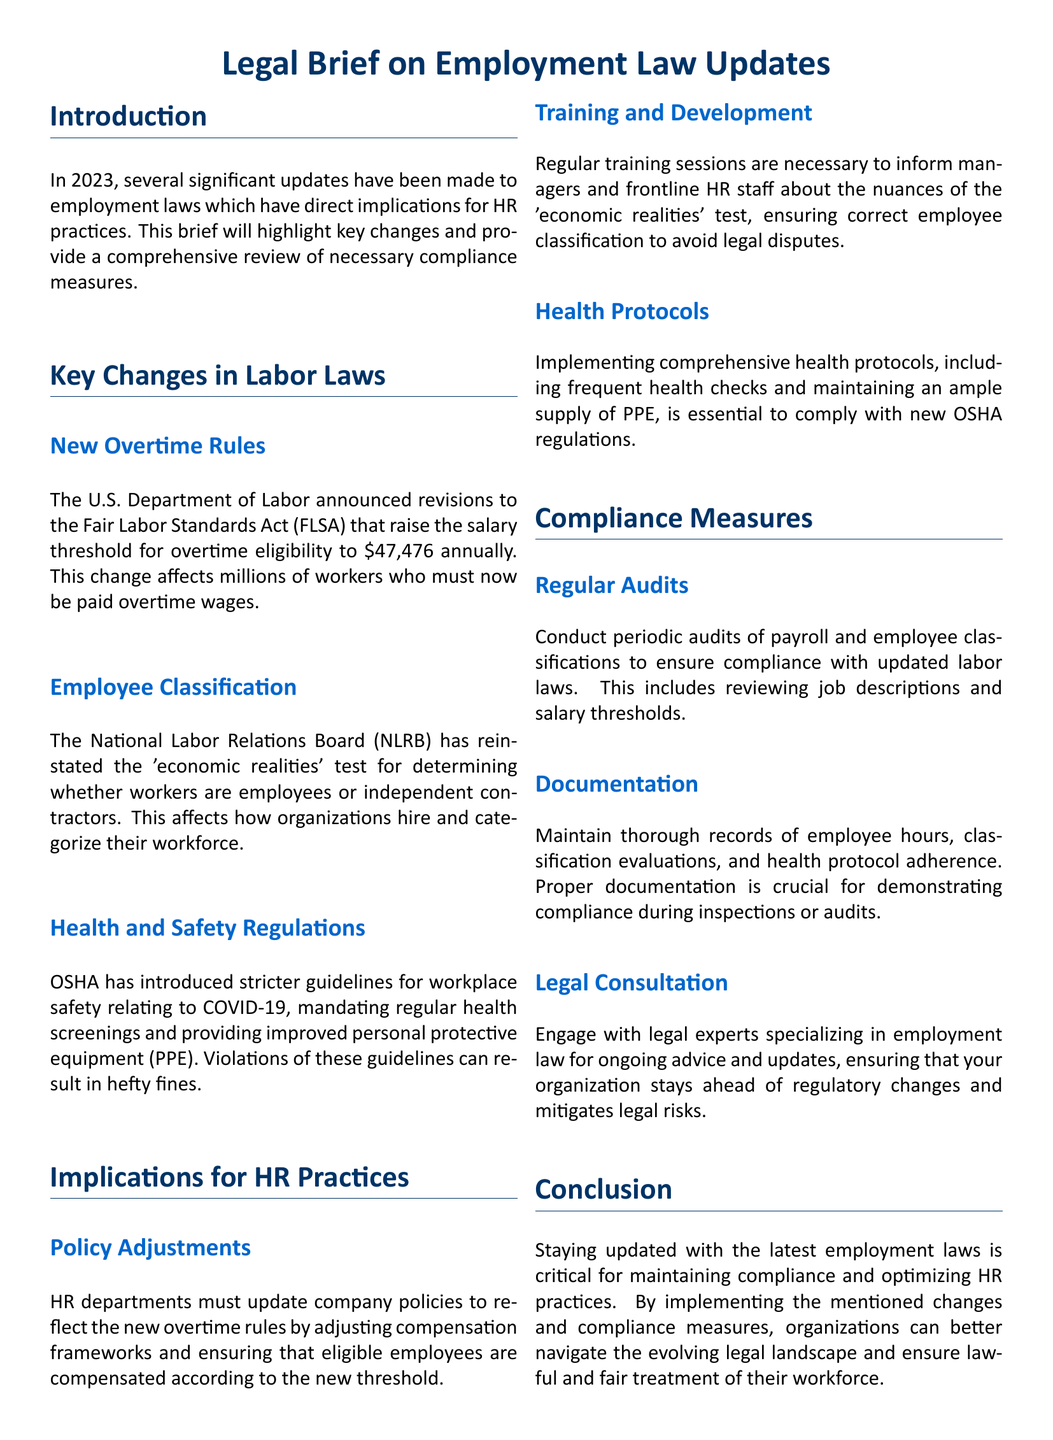What is the new salary threshold for overtime eligibility? The document states that the new salary threshold has been raised to $47,476 annually.
Answer: $47,476 What test was reinstated for employee classification? The document mentions that the 'economic realities' test was reinstated by the NLRB.
Answer: 'economic realities' test What organization introduced stricter workplace safety guidelines? The document notes that OSHA introduced the stricter guidelines for workplace safety.
Answer: OSHA What is one of the compliance measures mentioned for HR? The document lists conducting periodic audits of payroll and employee classifications as a compliance measure.
Answer: Regular audits What must HR update according to the new labor laws? The document indicates that HR departments must update company policies regarding compensation frameworks.
Answer: Company policies How often should training sessions be held for managers? The document emphasizes that regular training sessions are necessary, implying a frequent schedule.
Answer: Regularly What is one legal consultation sought by organizations? The document suggests engaging with legal experts specializing in employment law for ongoing advice.
Answer: Legal experts What kind of protocols should be implemented for health? The document advises implementing comprehensive health protocols, including health checks and PPE supply.
Answer: Comprehensive health protocols 